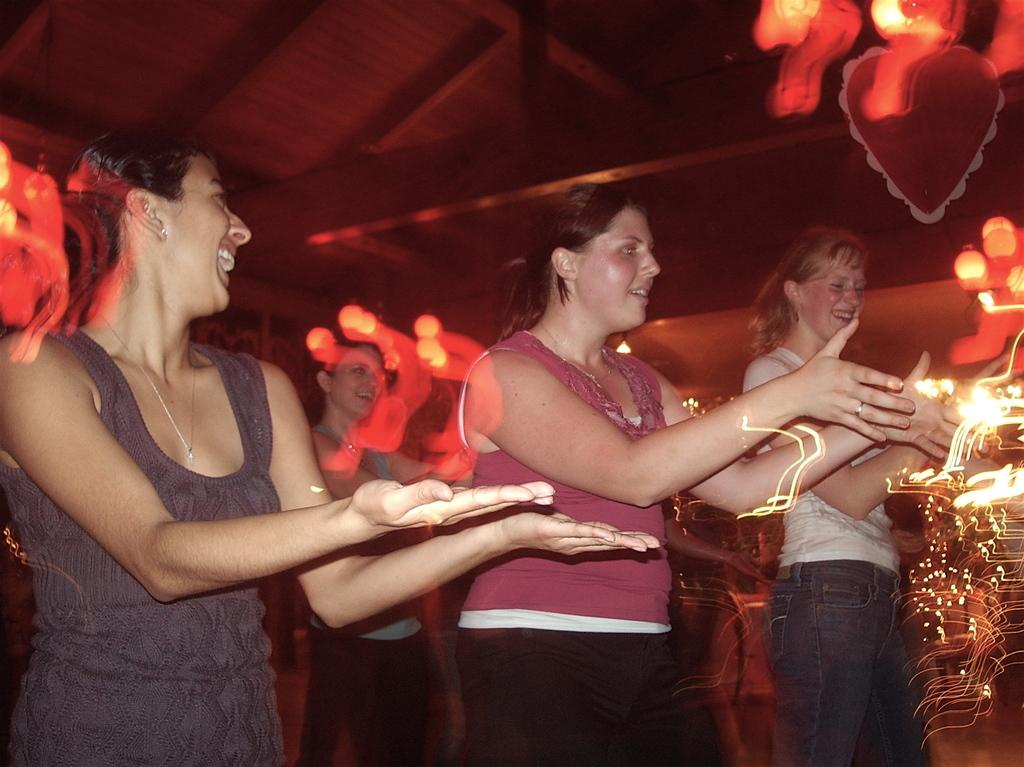Who or what can be seen in the image? There are people in the image. What type of surface is visible in the image? There is ground with objects in the image. What structure is partially visible in the image? There is a roof visible in the image. What can be used to provide illumination in the image? There are lights in the image. What type of corn is being used as a joke in the image? There is no corn or joke present in the image. What type of flag is visible in the image? There is no flag visible in the image. 